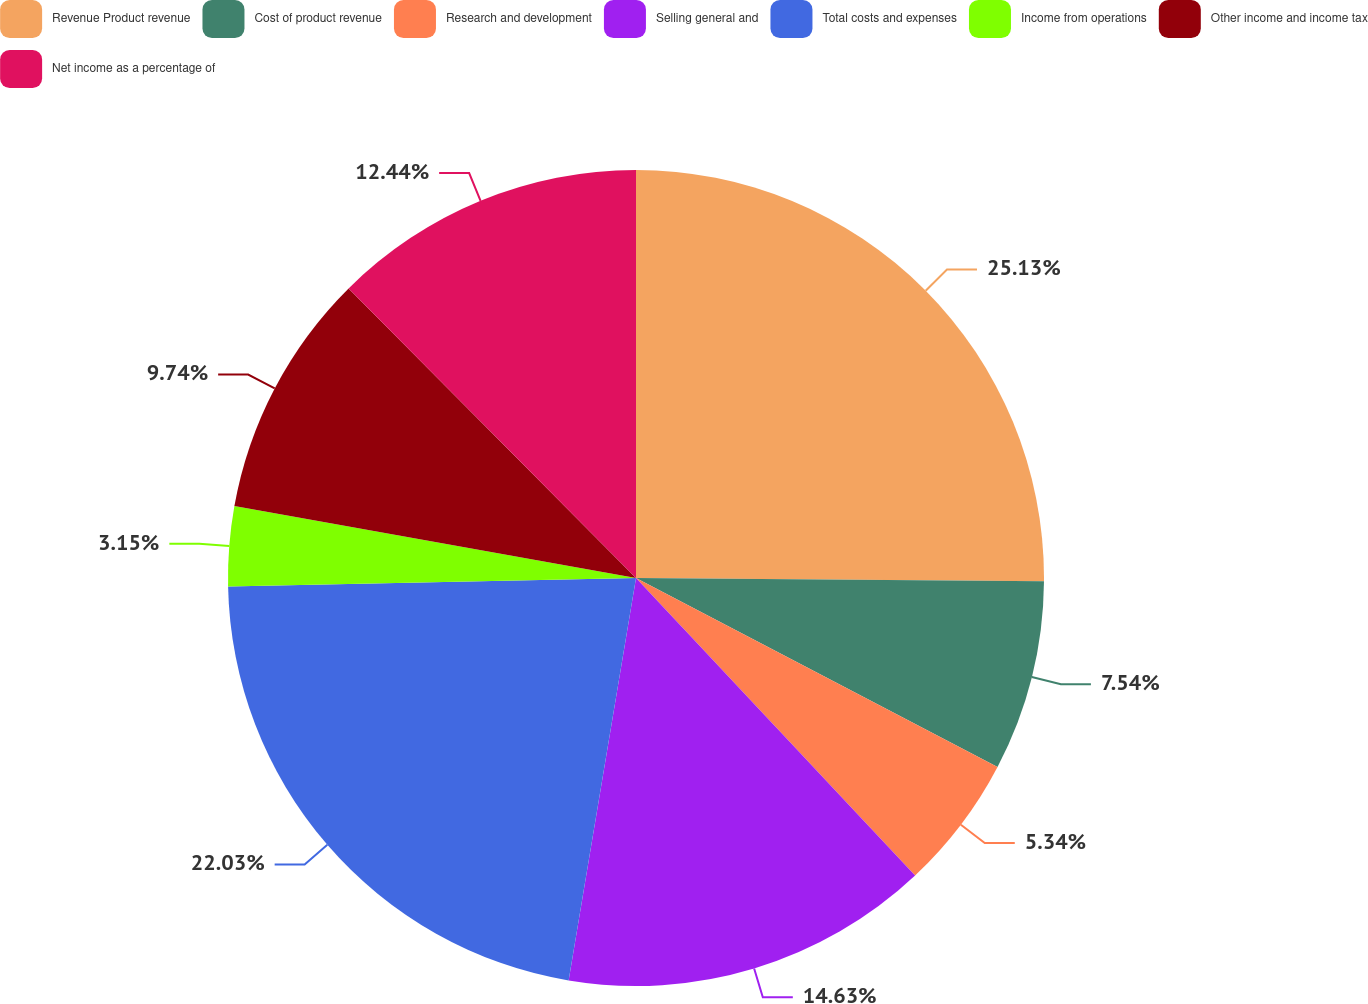Convert chart to OTSL. <chart><loc_0><loc_0><loc_500><loc_500><pie_chart><fcel>Revenue Product revenue<fcel>Cost of product revenue<fcel>Research and development<fcel>Selling general and<fcel>Total costs and expenses<fcel>Income from operations<fcel>Other income and income tax<fcel>Net income as a percentage of<nl><fcel>25.13%<fcel>7.54%<fcel>5.34%<fcel>14.63%<fcel>22.03%<fcel>3.15%<fcel>9.74%<fcel>12.44%<nl></chart> 